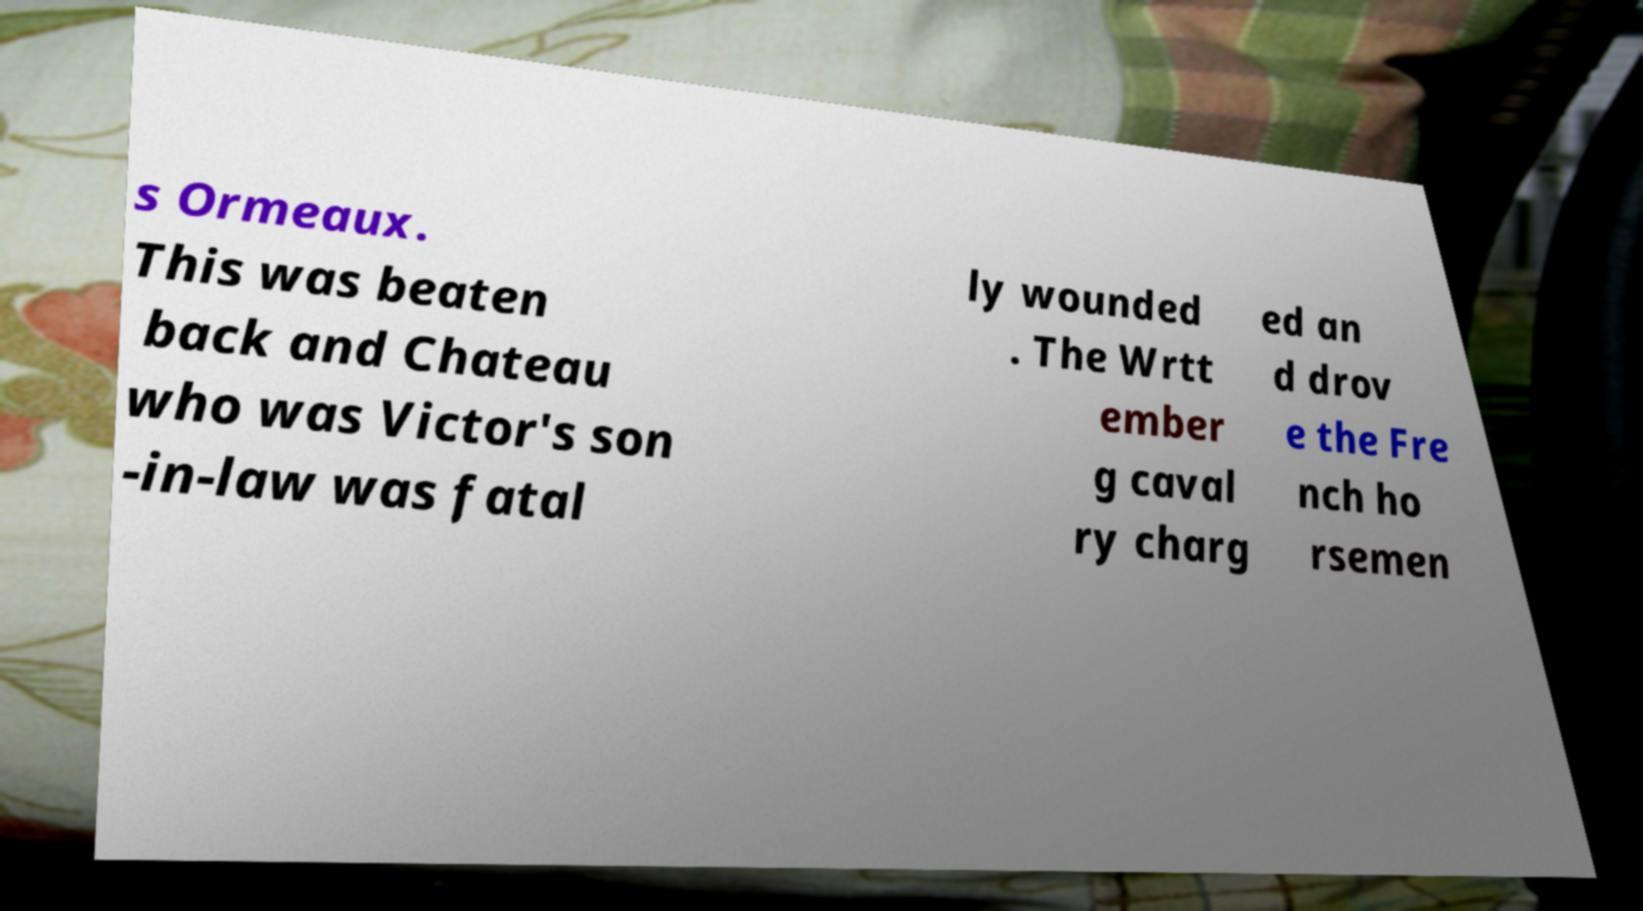What messages or text are displayed in this image? I need them in a readable, typed format. s Ormeaux. This was beaten back and Chateau who was Victor's son -in-law was fatal ly wounded . The Wrtt ember g caval ry charg ed an d drov e the Fre nch ho rsemen 